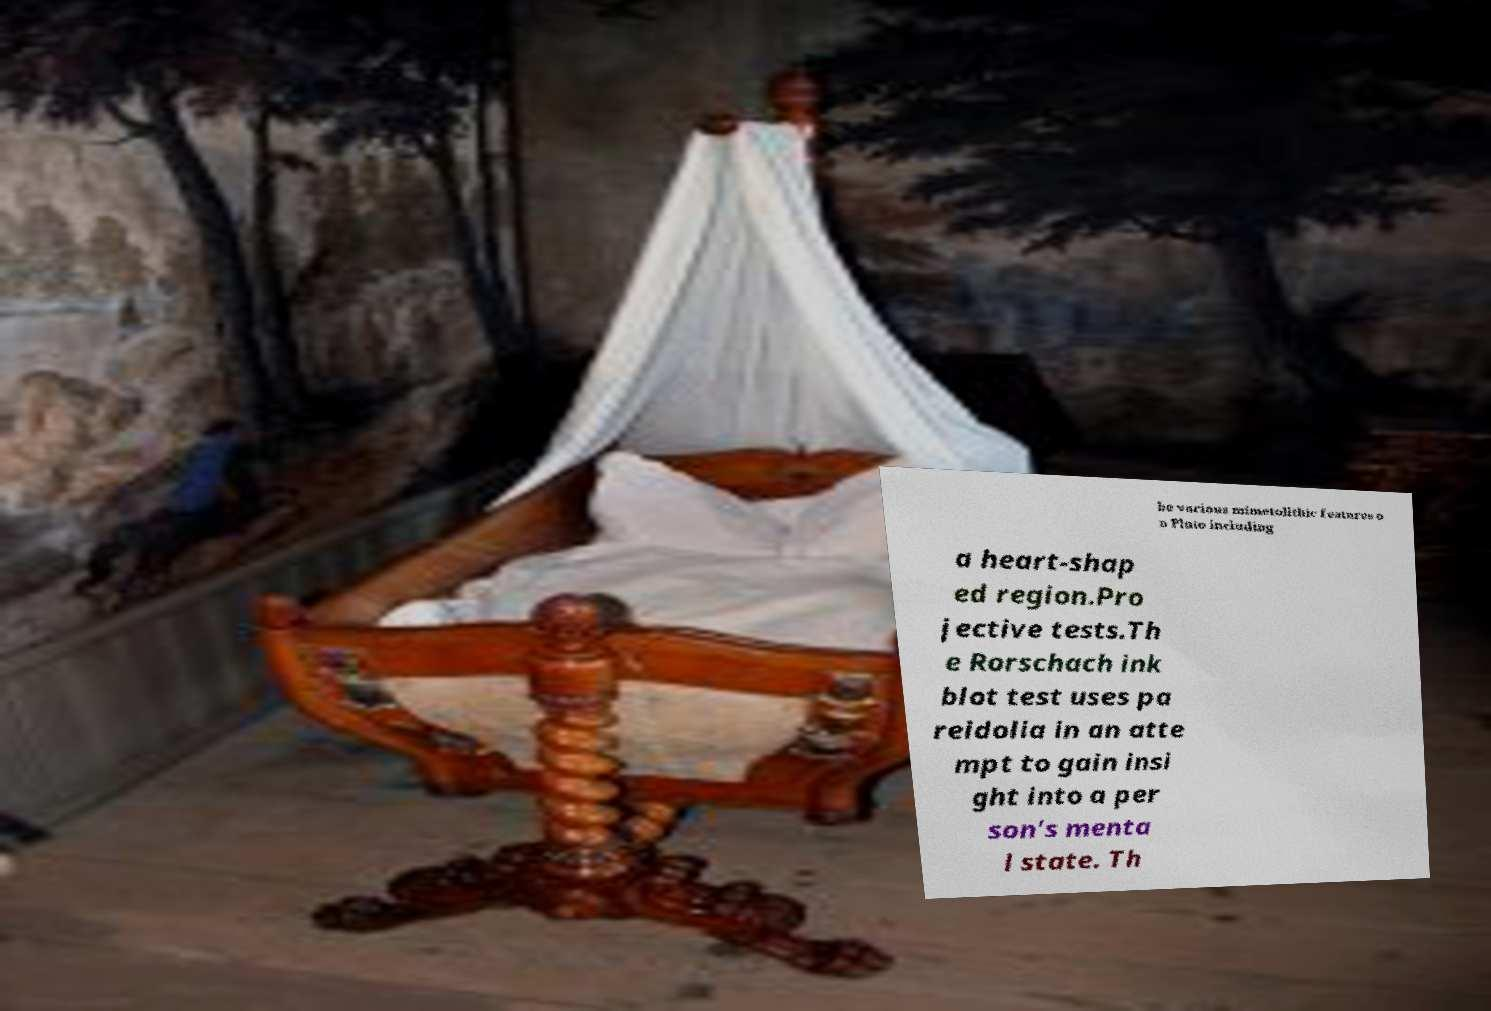Can you accurately transcribe the text from the provided image for me? be various mimetolithic features o n Pluto including a heart-shap ed region.Pro jective tests.Th e Rorschach ink blot test uses pa reidolia in an atte mpt to gain insi ght into a per son's menta l state. Th 